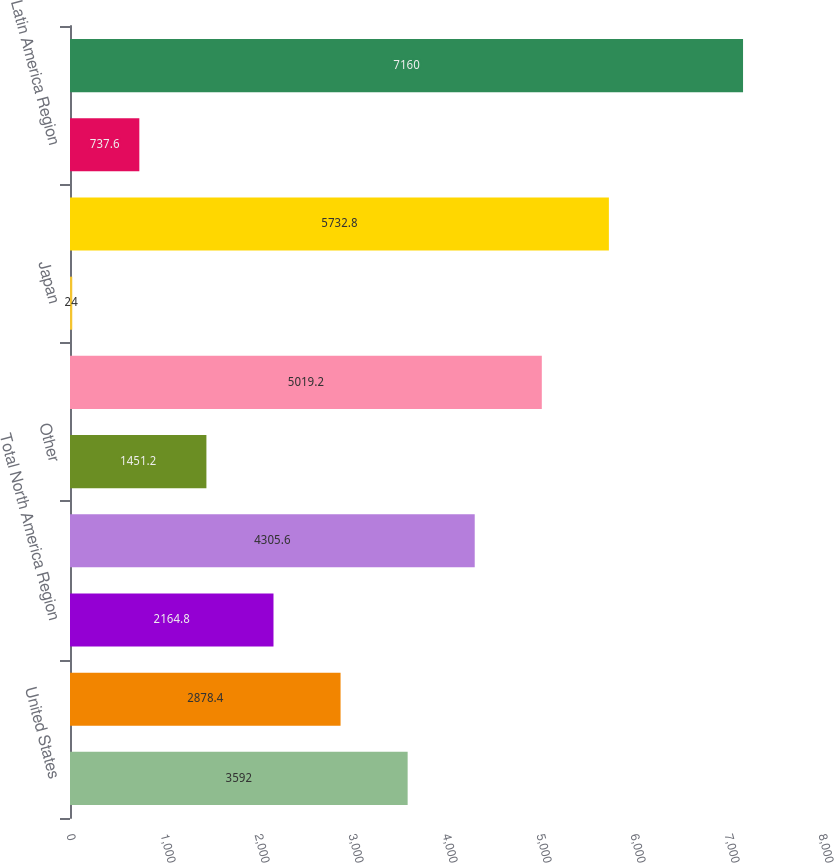<chart> <loc_0><loc_0><loc_500><loc_500><bar_chart><fcel>United States<fcel>Canada<fcel>Total North America Region<fcel>Europe (b)<fcel>Other<fcel>Total EMEA Region<fcel>Japan<fcel>Total Asia Pacific Region<fcel>Latin America Region<fcel>Total Worldwide Retail Sales<nl><fcel>3592<fcel>2878.4<fcel>2164.8<fcel>4305.6<fcel>1451.2<fcel>5019.2<fcel>24<fcel>5732.8<fcel>737.6<fcel>7160<nl></chart> 